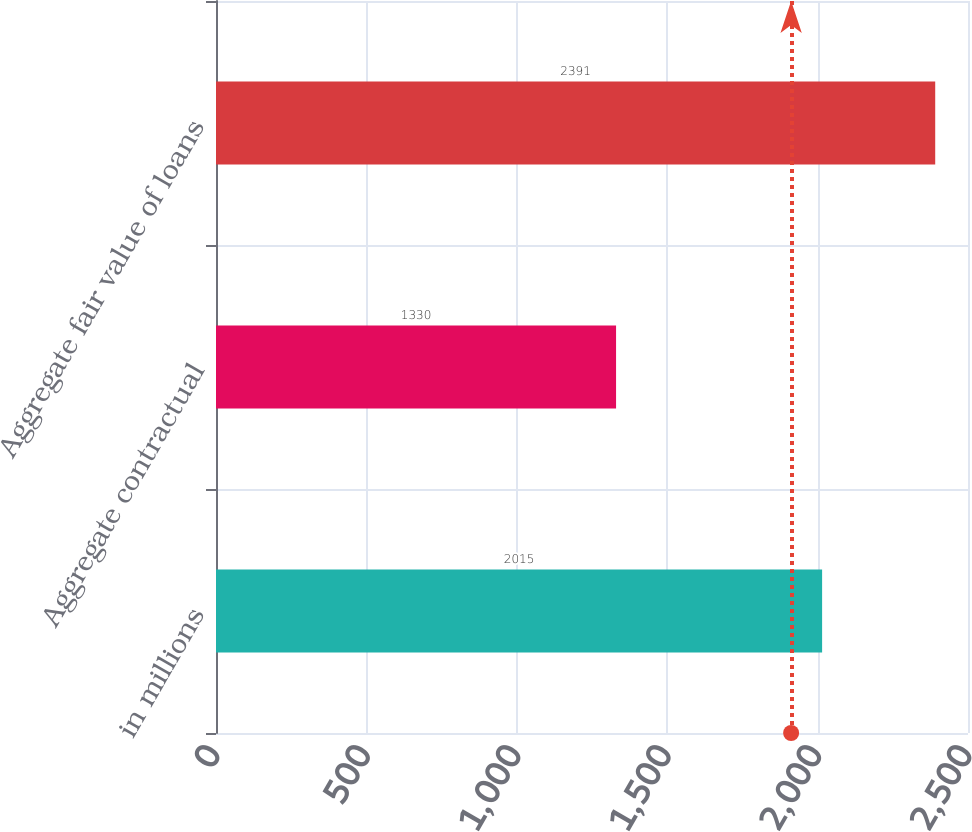<chart> <loc_0><loc_0><loc_500><loc_500><bar_chart><fcel>in millions<fcel>Aggregate contractual<fcel>Aggregate fair value of loans<nl><fcel>2015<fcel>1330<fcel>2391<nl></chart> 